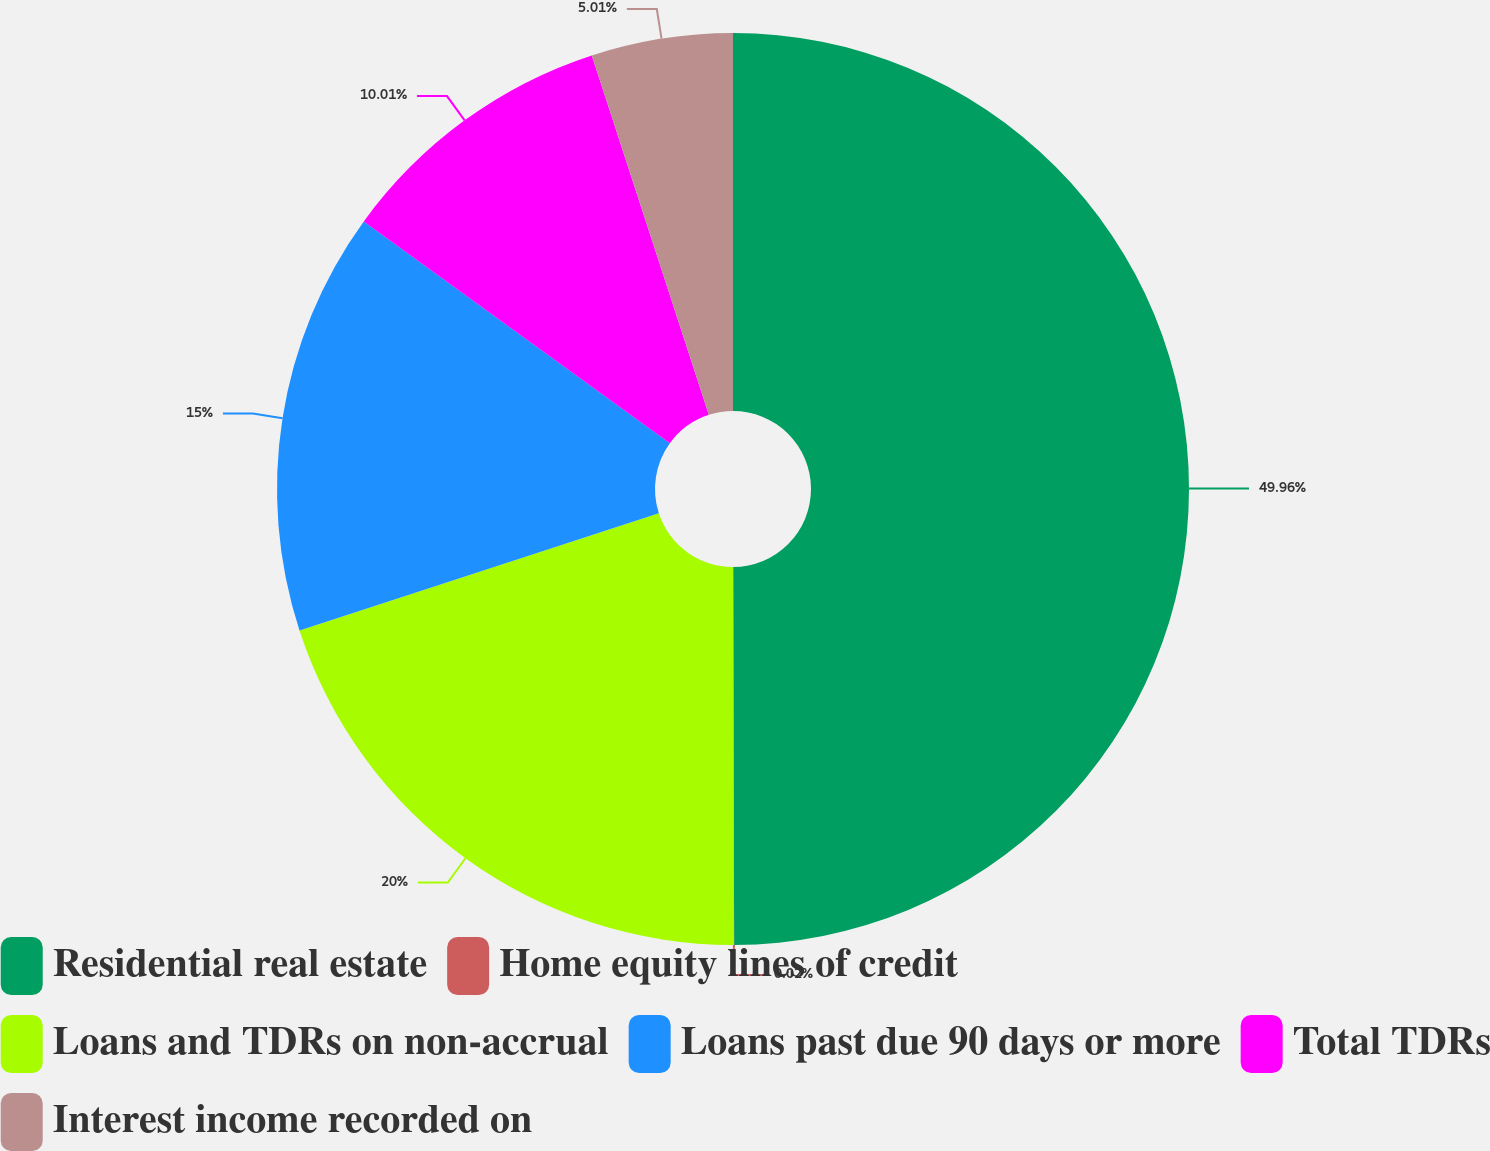Convert chart to OTSL. <chart><loc_0><loc_0><loc_500><loc_500><pie_chart><fcel>Residential real estate<fcel>Home equity lines of credit<fcel>Loans and TDRs on non-accrual<fcel>Loans past due 90 days or more<fcel>Total TDRs<fcel>Interest income recorded on<nl><fcel>49.96%<fcel>0.02%<fcel>20.0%<fcel>15.0%<fcel>10.01%<fcel>5.01%<nl></chart> 